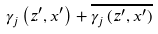<formula> <loc_0><loc_0><loc_500><loc_500>\gamma _ { j } \left ( z ^ { \prime } , x ^ { \prime } \right ) + \overline { \gamma _ { j } \left ( z ^ { \prime } , x ^ { \prime } \right ) }</formula> 